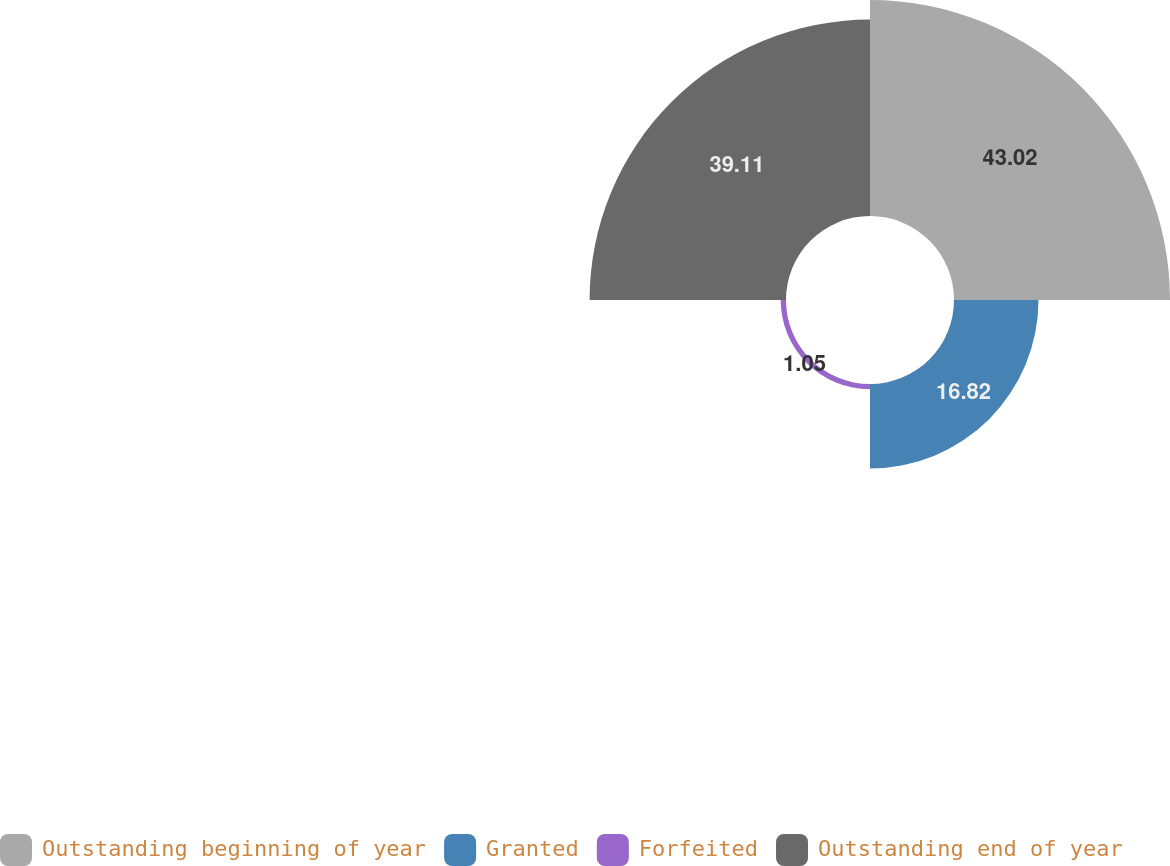<chart> <loc_0><loc_0><loc_500><loc_500><pie_chart><fcel>Outstanding beginning of year<fcel>Granted<fcel>Forfeited<fcel>Outstanding end of year<nl><fcel>43.01%<fcel>16.82%<fcel>1.05%<fcel>39.11%<nl></chart> 